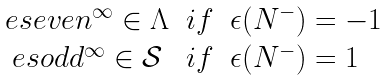<formula> <loc_0><loc_0><loc_500><loc_500>\begin{array} { c l l } { \ e s e v e n ^ { \infty } } \in \Lambda & i f & \epsilon ( N ^ { - } ) = - 1 \\ { \ e s o d d ^ { \infty } } \in \mathcal { S } & i f & \epsilon ( N ^ { - } ) = 1 \end{array}</formula> 